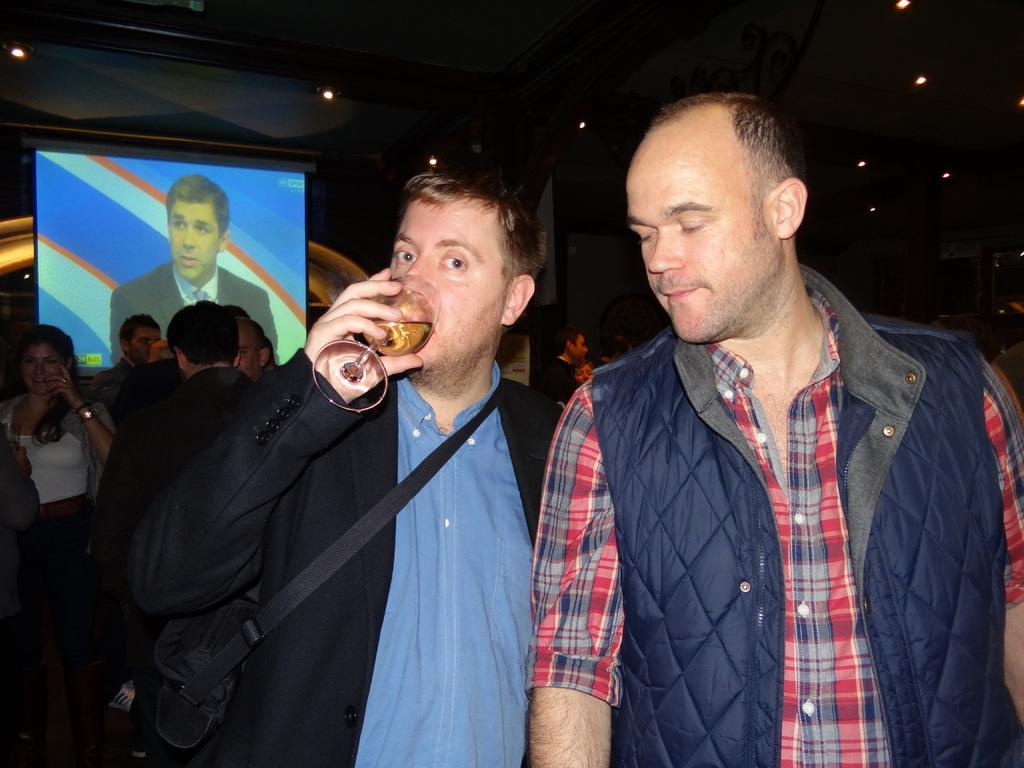How many men are standing in the image? There are two men standing in the image. What is one of the men doing? One man is drinking and holding a glass. What else is the man holding besides the glass? The man is also holding a wire bag. What can be seen in the background of the image? There are people, lights, and a screen in the background. What is displayed on the screen in the background? A man is visible on the screen. How much salt is on the table in the image? There is no salt visible in the image. Is there a frog hopping on the screen in the image? No, there is no frog present in the image; a man is visible on the screen. How many dimes are scattered on the floor in the image? There are no dimes visible in the image. 